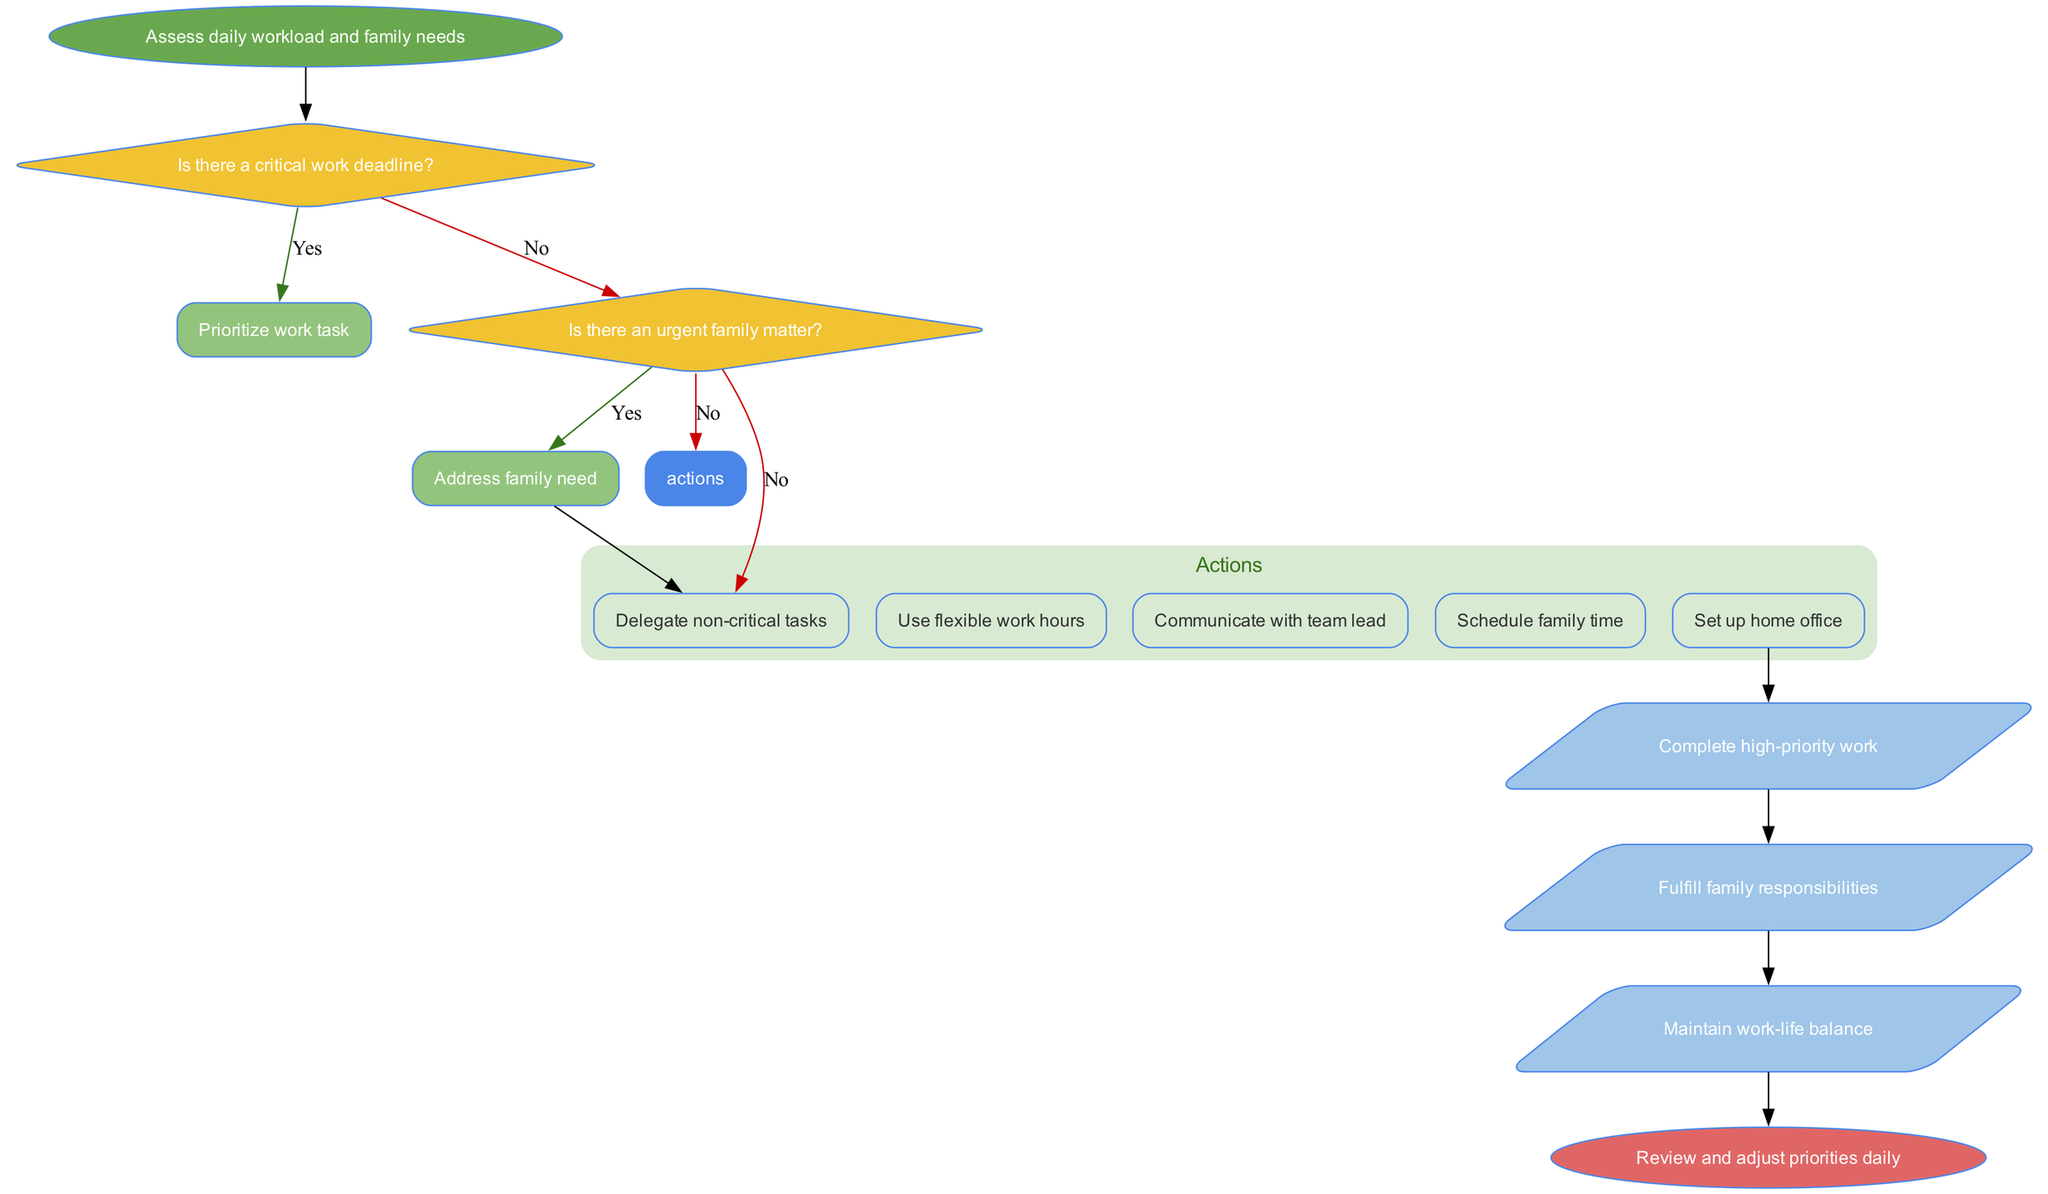What is the first step in the decision-making process? The diagram starts with the node labeled “Assess daily workload and family needs,” which signifies the initial action before any decisions are made.
Answer: Assess daily workload and family needs How many decision nodes are present in the diagram? By counting the decision nodes, I see there are two decisions about whether there's a critical work deadline and whether there's an urgent family matter.
Answer: 2 What happens if there is a critical work deadline? The Yes branch from the first decision node directs to the action of prioritizing the work task, showing that critical deadlines take precedence over other tasks.
Answer: Prioritize work task What action is taken if there is no urgent family matter? According to the flow, if there's no urgent family matter after evaluating the second decision, it leads to evaluating task importance.
Answer: Evaluate task importance What are the final outcomes represented in the diagram? The outcomes are represented after the action nodes, showing three results: complete high-priority work, fulfill family responsibilities, and maintain work-life balance.
Answer: Complete high-priority work, fulfill family responsibilities, maintain work-life balance What should you do after addressing a family need? The flow suggests that after addressing a family need, the next step would be to delegate non-critical tasks, allowing for better management of time and responsibilities.
Answer: Delegate non-critical tasks If you communicate with your team lead, what is one potential outcome you can expect? Communicating with the team lead is part of the action process that could lead to completing high-priority work, as it likely helps in aligning team efforts with deadlines.
Answer: Complete high-priority work What is the significance of the end node in this flowchart? The end node labeled “Review and adjust priorities daily” indicates the importance of continuous evaluation and adaption of strategies for managing work and family responsibilities.
Answer: Review and adjust priorities daily What effect does using flexible work hours have on work-life balance? Using flexible work hours is designed to help balance both work tasks and family responsibilities, facilitating a better integration of both spheres.
Answer: Maintain work-life balance 